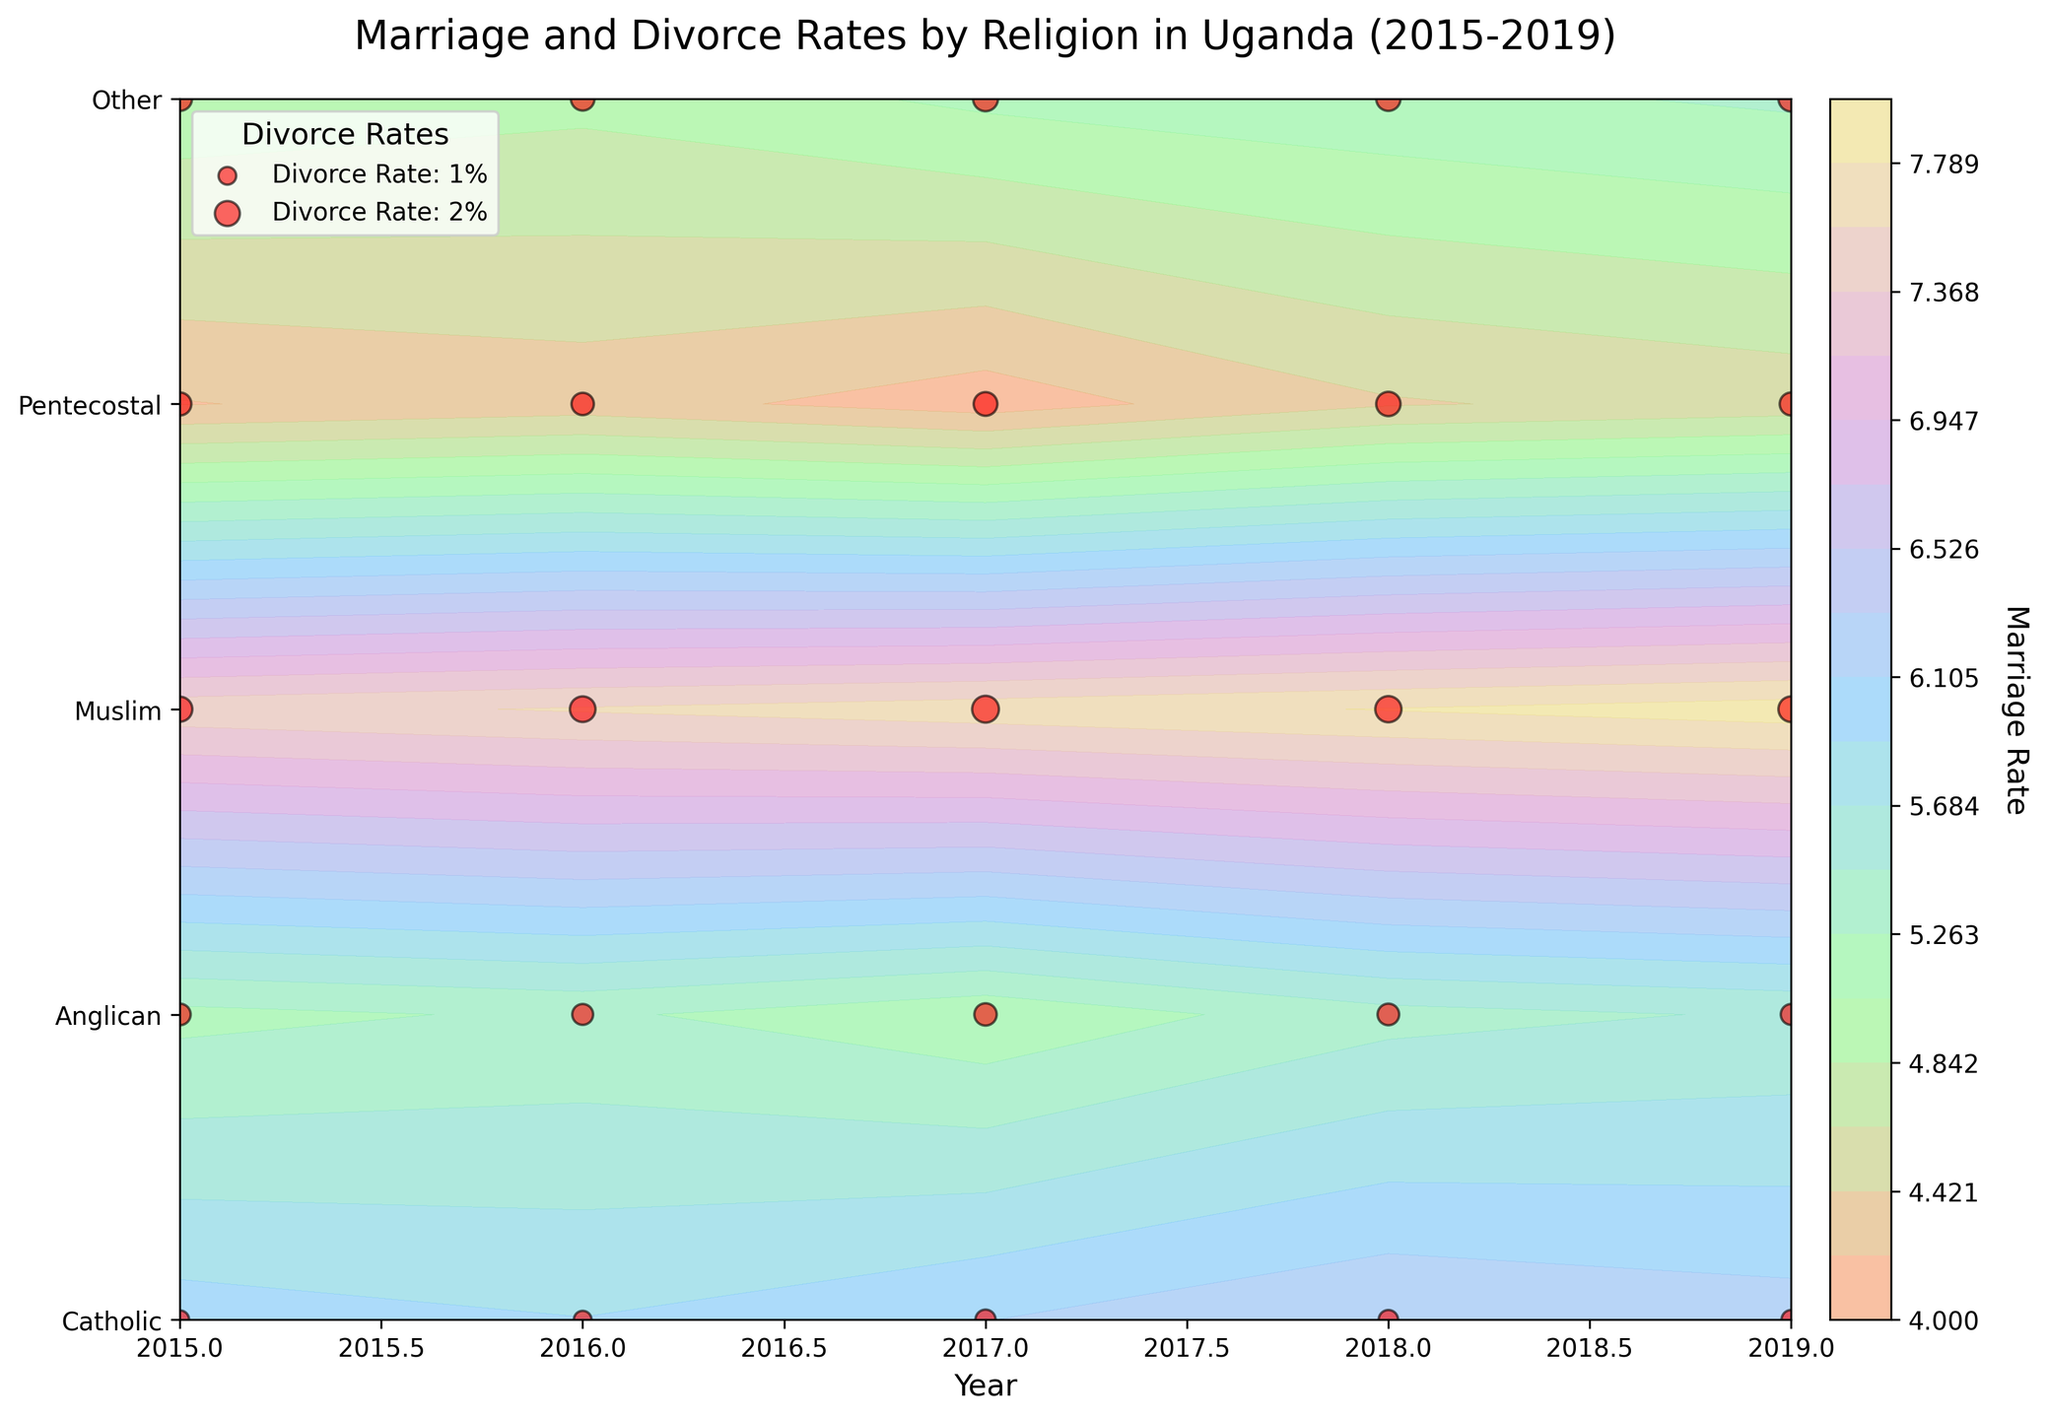What is the title of the figure? The title of the figure is located at the top and provides a brief summary of what the figure represents.
Answer: Marriage and Divorce Rates by Religion in Uganda (2015-2019) Which year had the highest marriage rate for Catholics? Look at the contour plot and identify the highest contour level for Catholics. Focus on the x-axis which represents the years and find the corresponding year.
Answer: 2019 How does the divorce rate for Pentecostals in 2017 compare to 2015? Locate the red scatter points for Pentecostals in 2015 and 2017, and compare their relative sizes. A larger red point indicates a higher divorce rate.
Answer: Higher in 2017 Can you identify any trend in the marriage rate for Muslims over the years? Analyze the contour levels along the timeline for Muslims. A consistent increase or decrease in the contour levels signifies a trend.
Answer: Increasing trend Which religion showed the lowest marriage rate in 2015? Find the contour levels for each religion in the year 2015. The contour level that is the furthest down indicates the lowest marriage rate.
Answer: Other What is the difference in divorce rate between Muslims and Anglicans in 2019? Compare the sizes of the red scatter points for Muslims and Anglicans in 2019. Subtract the Anglicans' rate from the Muslims' rate.
Answer: 0.7 Which religion showed the most stable marriage rate over the years? Observe the contour levels for each religion across the years. The religion with the least variation in contour intensity shows the most stability.
Answer: Catholic How does the marriage rate of Pentecostals in 2019 compare to that of Anglicans in the same year? Analyze the contour levels for both Pentecostals and Anglicans in 2019 and compare their positions.
Answer: Lower Which religion had the highest divorce rate overall during the period 2015-2019? Compare the sizes of the red scatter points across all years and religions. Identify the religion with consistently larger points.
Answer: Muslim What can you infer about the relationship between marriage and divorce rates for Catholics? Look at the shape and position of the contours for marriage rates and the scatter points for divorce rates for Catholics. Determine if there is a correlation or an inverse relation.
Answer: No clear relationship 